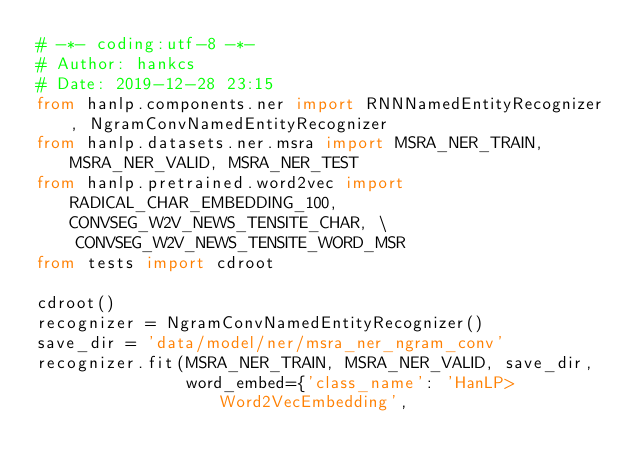Convert code to text. <code><loc_0><loc_0><loc_500><loc_500><_Python_># -*- coding:utf-8 -*-
# Author: hankcs
# Date: 2019-12-28 23:15
from hanlp.components.ner import RNNNamedEntityRecognizer, NgramConvNamedEntityRecognizer
from hanlp.datasets.ner.msra import MSRA_NER_TRAIN, MSRA_NER_VALID, MSRA_NER_TEST
from hanlp.pretrained.word2vec import RADICAL_CHAR_EMBEDDING_100, CONVSEG_W2V_NEWS_TENSITE_CHAR, \
    CONVSEG_W2V_NEWS_TENSITE_WORD_MSR
from tests import cdroot

cdroot()
recognizer = NgramConvNamedEntityRecognizer()
save_dir = 'data/model/ner/msra_ner_ngram_conv'
recognizer.fit(MSRA_NER_TRAIN, MSRA_NER_VALID, save_dir,
               word_embed={'class_name': 'HanLP>Word2VecEmbedding',</code> 